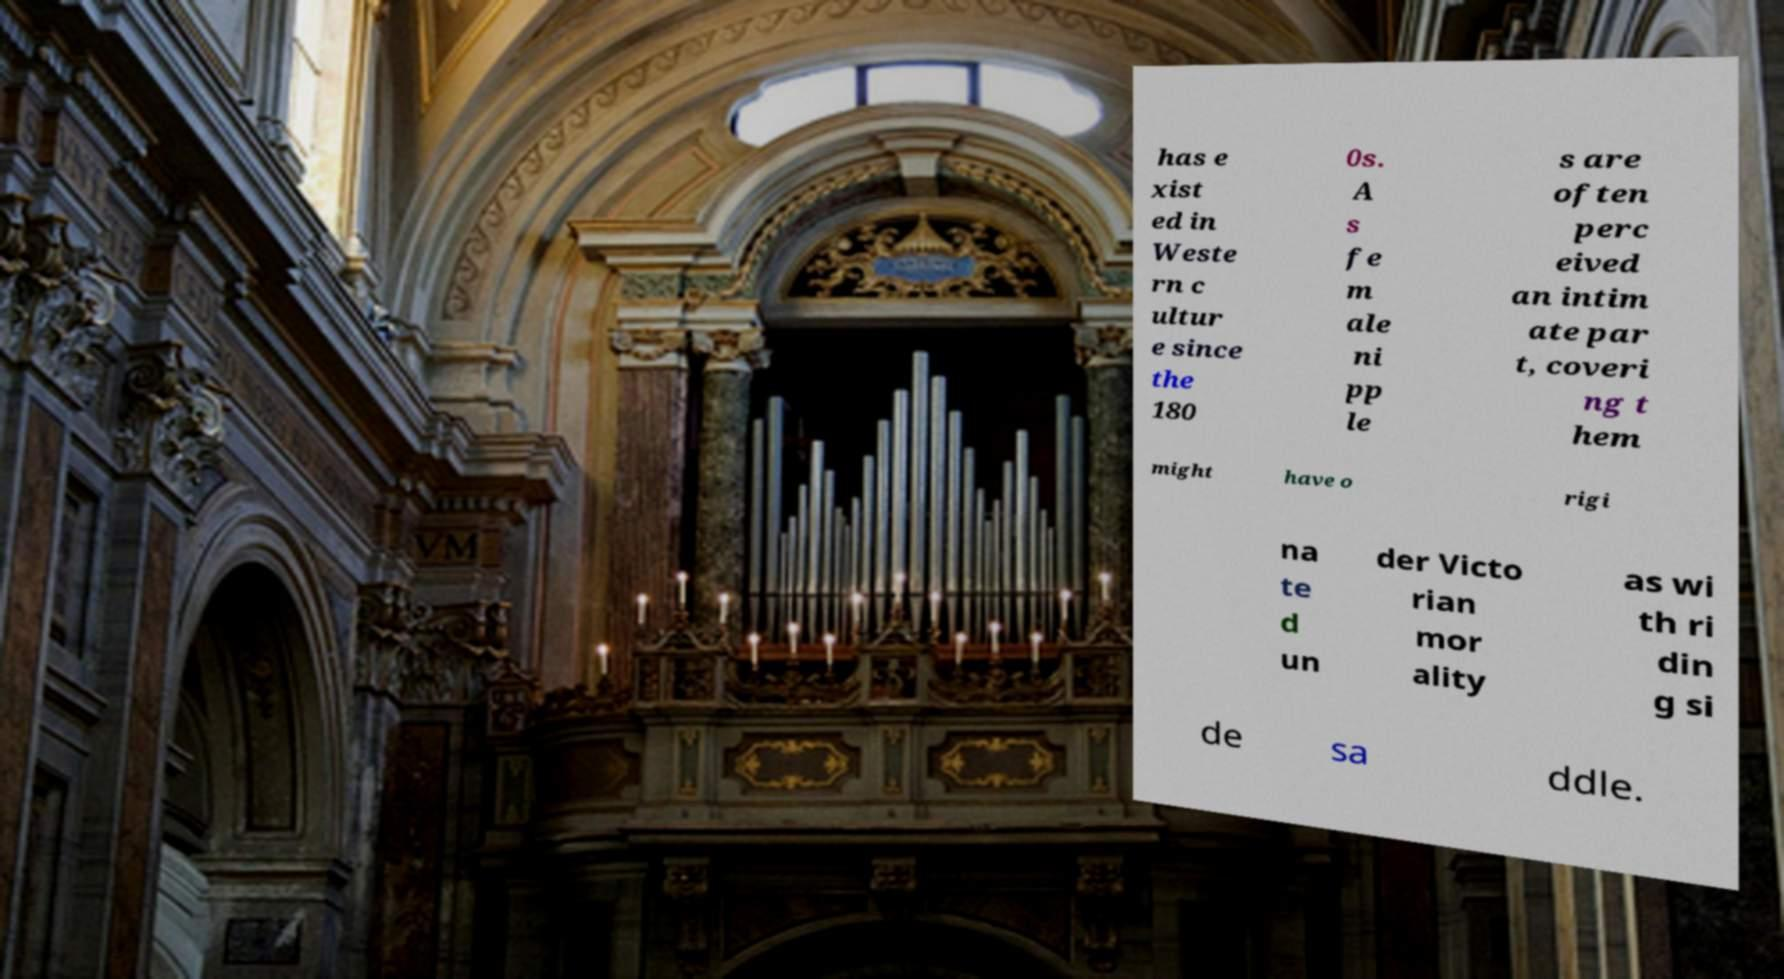Can you read and provide the text displayed in the image?This photo seems to have some interesting text. Can you extract and type it out for me? has e xist ed in Weste rn c ultur e since the 180 0s. A s fe m ale ni pp le s are often perc eived an intim ate par t, coveri ng t hem might have o rigi na te d un der Victo rian mor ality as wi th ri din g si de sa ddle. 